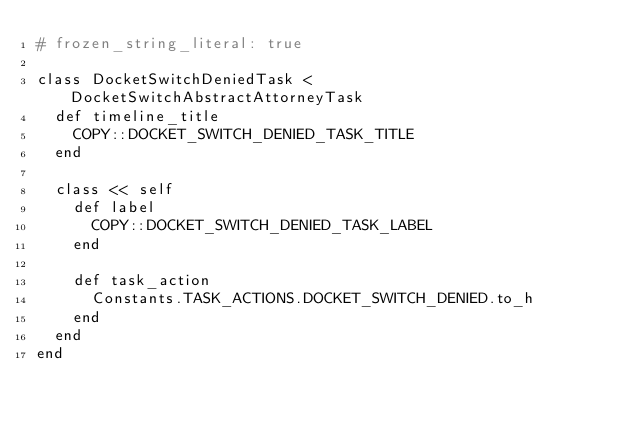<code> <loc_0><loc_0><loc_500><loc_500><_Ruby_># frozen_string_literal: true

class DocketSwitchDeniedTask < DocketSwitchAbstractAttorneyTask
  def timeline_title
    COPY::DOCKET_SWITCH_DENIED_TASK_TITLE
  end

  class << self
    def label
      COPY::DOCKET_SWITCH_DENIED_TASK_LABEL
    end

    def task_action
      Constants.TASK_ACTIONS.DOCKET_SWITCH_DENIED.to_h
    end
  end
end
</code> 